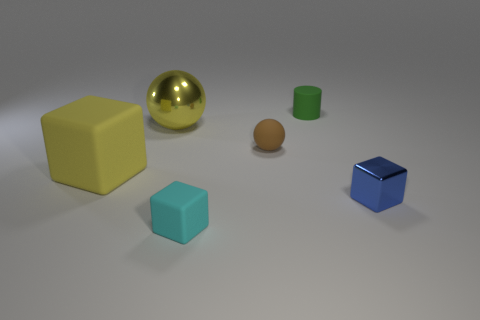Add 1 blue cubes. How many objects exist? 7 Subtract all spheres. How many objects are left? 4 Subtract all big purple metallic balls. Subtract all tiny rubber things. How many objects are left? 3 Add 4 large yellow rubber cubes. How many large yellow rubber cubes are left? 5 Add 4 blue objects. How many blue objects exist? 5 Subtract 0 cyan cylinders. How many objects are left? 6 